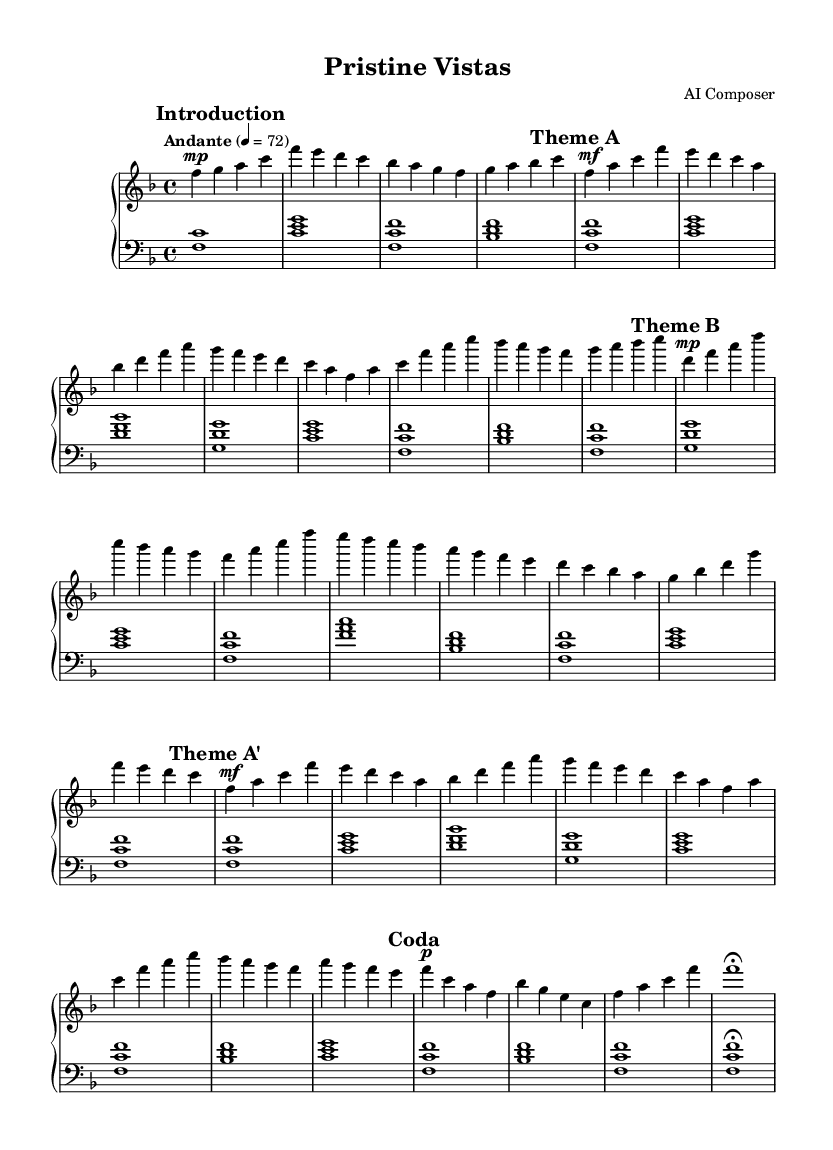What is the key signature of this music? The key signature is F major, which has one flat (B flat). This is identified by looking at the key signature indicated at the beginning of the sheet music.
Answer: F major What is the time signature of this piece? The time signature is 4/4, indicated by the fraction at the beginning of the score. This means there are four beats in each measure, and the quarter note receives one beat.
Answer: 4/4 What is the tempo indicated for this piece? The tempo is marked as "Andante" with a metronome marking of 72. This indicates a moderately slow tempo. The term "Andante" is typically associated with a walking pace.
Answer: Andante, 72 How many distinct themes are present in this composition? The composition features three distinct themes labeled as Theme A, Theme B, and Theme A prime (A'). This can be determined by observing the sections marked in the score.
Answer: Three What is the dynamic marking at the beginning of Theme A? The dynamic marking at the beginning of Theme A is "mf," which stands for mezzo-forte, meaning moderately loud. This is indicated in the sheet music right before Theme A starts.
Answer: mf What is the last measure's note value in the Coda section? The last measure in the Coda section has a note value of a whole note (f1) followed by a fermata symbol. This indicates that the note should be held longer than its typical duration.
Answer: f1 